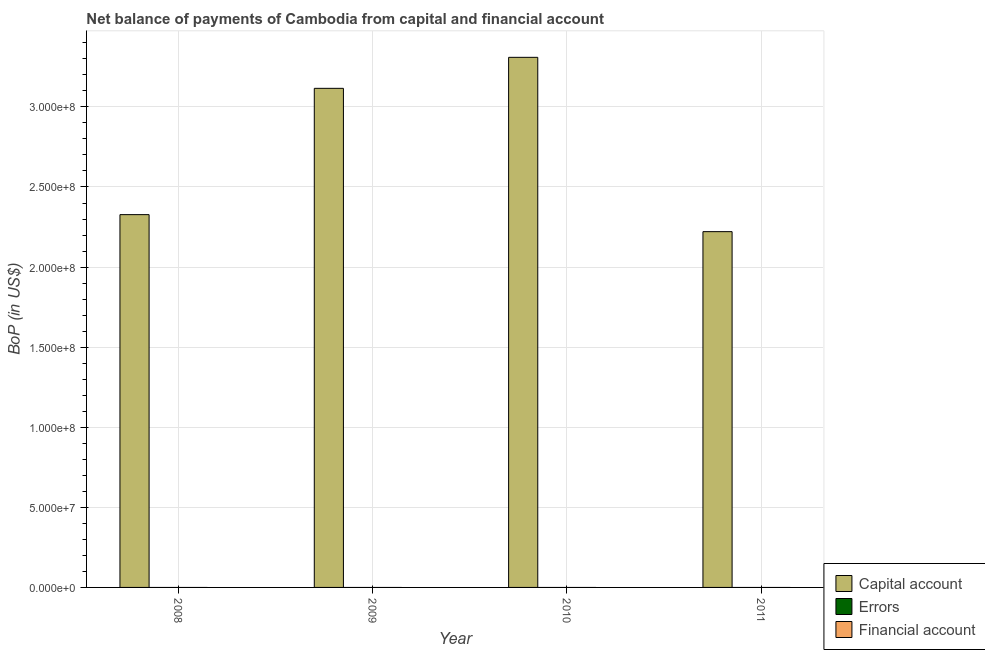Are the number of bars per tick equal to the number of legend labels?
Your answer should be compact. No. Are the number of bars on each tick of the X-axis equal?
Offer a very short reply. Yes. How many bars are there on the 4th tick from the left?
Provide a succinct answer. 1. What is the label of the 4th group of bars from the left?
Keep it short and to the point. 2011. What is the amount of errors in 2009?
Your response must be concise. 0. Across all years, what is the maximum amount of net capital account?
Offer a terse response. 3.31e+08. Across all years, what is the minimum amount of errors?
Give a very brief answer. 0. In which year was the amount of net capital account maximum?
Ensure brevity in your answer.  2010. What is the total amount of errors in the graph?
Ensure brevity in your answer.  0. What is the difference between the amount of net capital account in 2009 and that in 2010?
Provide a short and direct response. -1.94e+07. What is the difference between the amount of net capital account in 2010 and the amount of errors in 2008?
Provide a succinct answer. 9.82e+07. In the year 2009, what is the difference between the amount of net capital account and amount of financial account?
Make the answer very short. 0. In how many years, is the amount of financial account greater than 200000000 US$?
Your answer should be very brief. 0. What is the ratio of the amount of net capital account in 2009 to that in 2011?
Provide a succinct answer. 1.4. Is the difference between the amount of net capital account in 2008 and 2010 greater than the difference between the amount of errors in 2008 and 2010?
Ensure brevity in your answer.  No. What is the difference between the highest and the second highest amount of net capital account?
Give a very brief answer. 1.94e+07. What is the difference between the highest and the lowest amount of net capital account?
Your answer should be very brief. 1.09e+08. In how many years, is the amount of financial account greater than the average amount of financial account taken over all years?
Provide a succinct answer. 0. Is the sum of the amount of net capital account in 2008 and 2011 greater than the maximum amount of errors across all years?
Offer a terse response. Yes. Is it the case that in every year, the sum of the amount of net capital account and amount of errors is greater than the amount of financial account?
Your answer should be very brief. Yes. How many bars are there?
Keep it short and to the point. 4. Does the graph contain grids?
Give a very brief answer. Yes. How are the legend labels stacked?
Provide a succinct answer. Vertical. What is the title of the graph?
Provide a short and direct response. Net balance of payments of Cambodia from capital and financial account. Does "Coal sources" appear as one of the legend labels in the graph?
Keep it short and to the point. No. What is the label or title of the X-axis?
Give a very brief answer. Year. What is the label or title of the Y-axis?
Make the answer very short. BoP (in US$). What is the BoP (in US$) in Capital account in 2008?
Offer a very short reply. 2.33e+08. What is the BoP (in US$) of Capital account in 2009?
Provide a succinct answer. 3.12e+08. What is the BoP (in US$) of Capital account in 2010?
Offer a terse response. 3.31e+08. What is the BoP (in US$) of Errors in 2010?
Give a very brief answer. 0. What is the BoP (in US$) in Capital account in 2011?
Ensure brevity in your answer.  2.22e+08. Across all years, what is the maximum BoP (in US$) of Capital account?
Your answer should be compact. 3.31e+08. Across all years, what is the minimum BoP (in US$) in Capital account?
Offer a very short reply. 2.22e+08. What is the total BoP (in US$) in Capital account in the graph?
Your response must be concise. 1.10e+09. What is the total BoP (in US$) in Financial account in the graph?
Offer a very short reply. 0. What is the difference between the BoP (in US$) of Capital account in 2008 and that in 2009?
Make the answer very short. -7.89e+07. What is the difference between the BoP (in US$) in Capital account in 2008 and that in 2010?
Your answer should be compact. -9.82e+07. What is the difference between the BoP (in US$) in Capital account in 2008 and that in 2011?
Provide a short and direct response. 1.06e+07. What is the difference between the BoP (in US$) in Capital account in 2009 and that in 2010?
Offer a terse response. -1.94e+07. What is the difference between the BoP (in US$) in Capital account in 2009 and that in 2011?
Your answer should be compact. 8.95e+07. What is the difference between the BoP (in US$) of Capital account in 2010 and that in 2011?
Offer a terse response. 1.09e+08. What is the average BoP (in US$) in Capital account per year?
Your answer should be very brief. 2.74e+08. What is the ratio of the BoP (in US$) in Capital account in 2008 to that in 2009?
Provide a succinct answer. 0.75. What is the ratio of the BoP (in US$) in Capital account in 2008 to that in 2010?
Provide a succinct answer. 0.7. What is the ratio of the BoP (in US$) in Capital account in 2008 to that in 2011?
Provide a succinct answer. 1.05. What is the ratio of the BoP (in US$) of Capital account in 2009 to that in 2010?
Your answer should be very brief. 0.94. What is the ratio of the BoP (in US$) in Capital account in 2009 to that in 2011?
Give a very brief answer. 1.4. What is the ratio of the BoP (in US$) in Capital account in 2010 to that in 2011?
Your answer should be compact. 1.49. What is the difference between the highest and the second highest BoP (in US$) of Capital account?
Your response must be concise. 1.94e+07. What is the difference between the highest and the lowest BoP (in US$) of Capital account?
Offer a very short reply. 1.09e+08. 